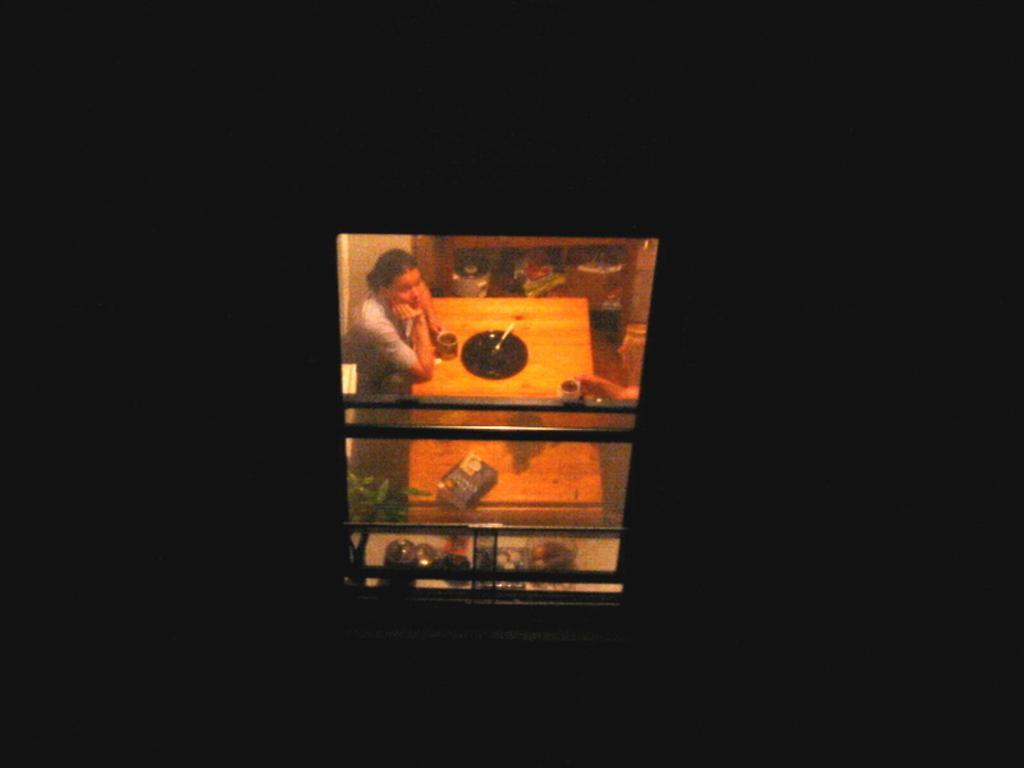Please provide a concise description of this image. In this image there is a wall having a window. Behind the window there is a woman standing near the table. On the table there is a plate, cup and a book are on it. Beside the women there are few plants. Few objects are on the shelf. Right side there is a person's hand holding a cup is visible. 